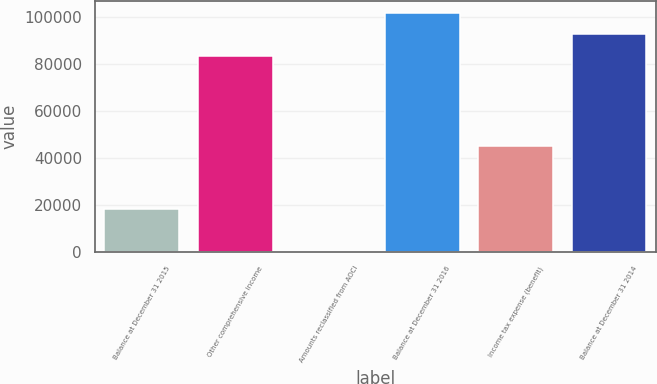<chart> <loc_0><loc_0><loc_500><loc_500><bar_chart><fcel>Balance at December 31 2015<fcel>Other comprehensive income<fcel>Amounts reclassified from AOCI<fcel>Balance at December 31 2016<fcel>Income tax expense (benefit)<fcel>Balance at December 31 2014<nl><fcel>18369<fcel>83220.4<fcel>63<fcel>101691<fcel>44898<fcel>92455.8<nl></chart> 